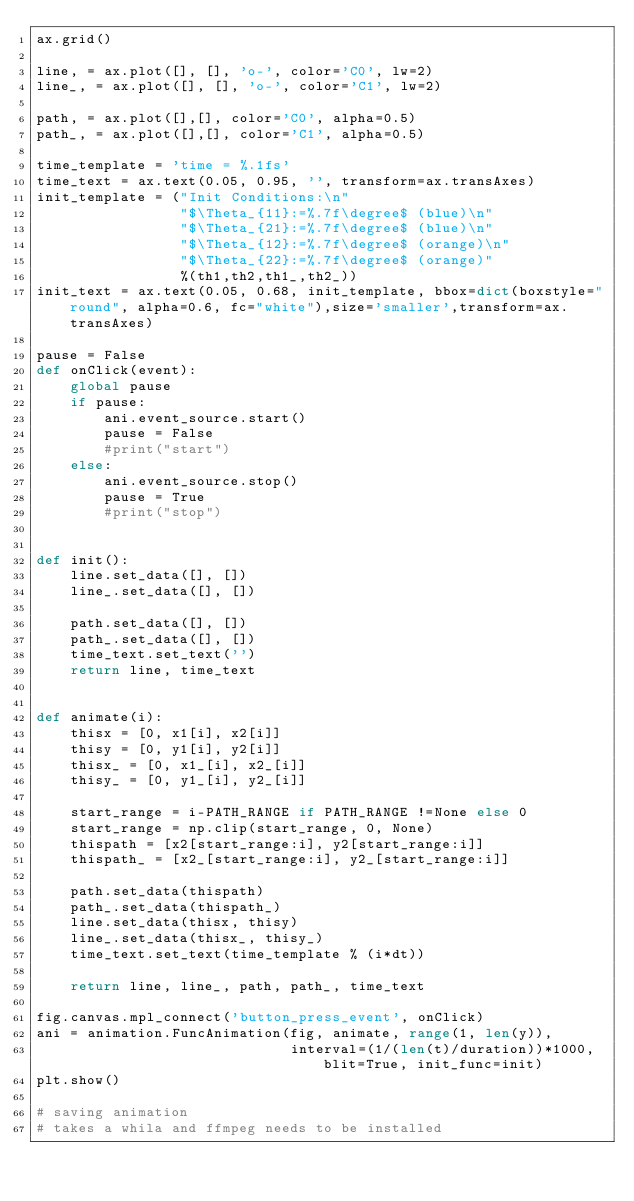Convert code to text. <code><loc_0><loc_0><loc_500><loc_500><_Python_>ax.grid()

line, = ax.plot([], [], 'o-', color='C0', lw=2)
line_, = ax.plot([], [], 'o-', color='C1', lw=2)

path, = ax.plot([],[], color='C0', alpha=0.5)
path_, = ax.plot([],[], color='C1', alpha=0.5)

time_template = 'time = %.1fs'
time_text = ax.text(0.05, 0.95, '', transform=ax.transAxes)
init_template = ("Init Conditions:\n"
                 "$\Theta_{11}:=%.7f\degree$ (blue)\n"
                 "$\Theta_{21}:=%.7f\degree$ (blue)\n"
                 "$\Theta_{12}:=%.7f\degree$ (orange)\n"
                 "$\Theta_{22}:=%.7f\degree$ (orange)"
                 %(th1,th2,th1_,th2_))
init_text = ax.text(0.05, 0.68, init_template, bbox=dict(boxstyle="round", alpha=0.6, fc="white"),size='smaller',transform=ax.transAxes)

pause = False
def onClick(event):
    global pause
    if pause:
        ani.event_source.start()
        pause = False
        #print("start")
    else:
        ani.event_source.stop()
        pause = True
        #print("stop")
        

def init():
    line.set_data([], [])
    line_.set_data([], [])
    
    path.set_data([], [])
    path_.set_data([], [])
    time_text.set_text('')
    return line, time_text


def animate(i):
    thisx = [0, x1[i], x2[i]]
    thisy = [0, y1[i], y2[i]]
    thisx_ = [0, x1_[i], x2_[i]]
    thisy_ = [0, y1_[i], y2_[i]]
    
    start_range = i-PATH_RANGE if PATH_RANGE !=None else 0
    start_range = np.clip(start_range, 0, None)
    thispath = [x2[start_range:i], y2[start_range:i]]
    thispath_ = [x2_[start_range:i], y2_[start_range:i]]

    path.set_data(thispath)
    path_.set_data(thispath_)
    line.set_data(thisx, thisy)
    line_.set_data(thisx_, thisy_)
    time_text.set_text(time_template % (i*dt))
        
    return line, line_, path, path_, time_text

fig.canvas.mpl_connect('button_press_event', onClick)
ani = animation.FuncAnimation(fig, animate, range(1, len(y)),
                              interval=(1/(len(t)/duration))*1000, blit=True, init_func=init)
plt.show()

# saving animation
# takes a whila and ffmpeg needs to be installed</code> 